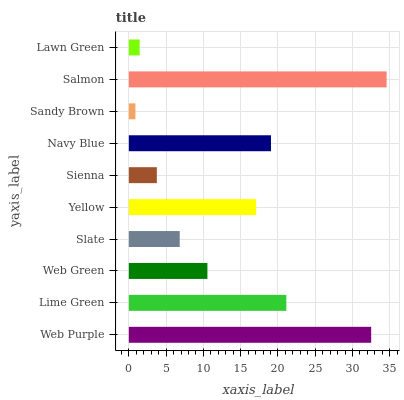Is Sandy Brown the minimum?
Answer yes or no. Yes. Is Salmon the maximum?
Answer yes or no. Yes. Is Lime Green the minimum?
Answer yes or no. No. Is Lime Green the maximum?
Answer yes or no. No. Is Web Purple greater than Lime Green?
Answer yes or no. Yes. Is Lime Green less than Web Purple?
Answer yes or no. Yes. Is Lime Green greater than Web Purple?
Answer yes or no. No. Is Web Purple less than Lime Green?
Answer yes or no. No. Is Yellow the high median?
Answer yes or no. Yes. Is Web Green the low median?
Answer yes or no. Yes. Is Navy Blue the high median?
Answer yes or no. No. Is Web Purple the low median?
Answer yes or no. No. 